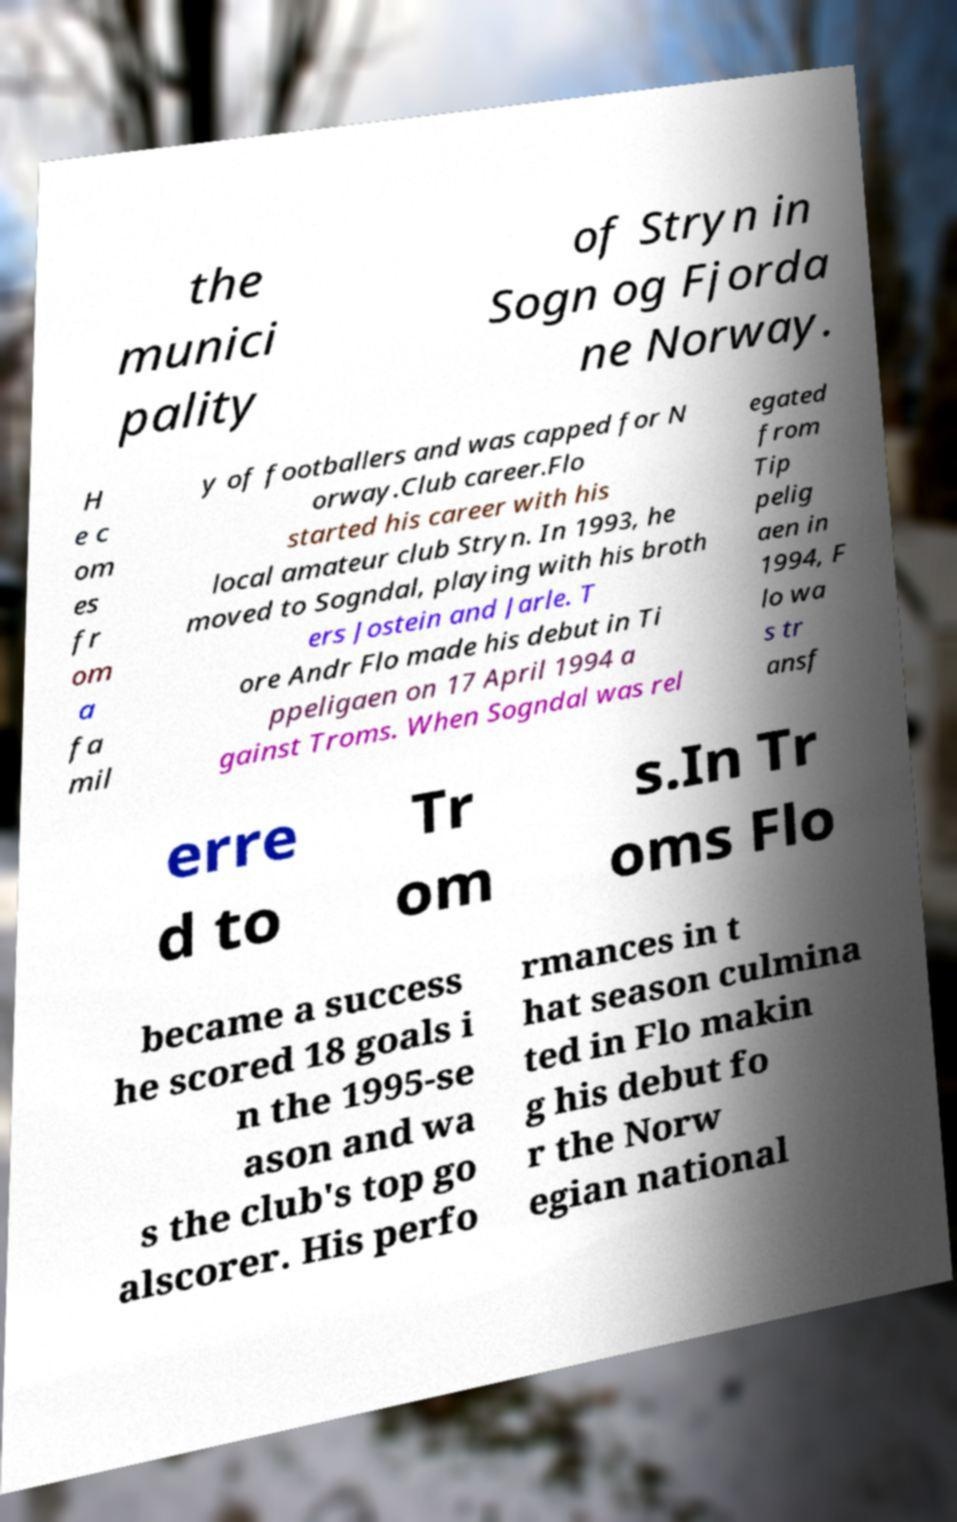Could you extract and type out the text from this image? the munici pality of Stryn in Sogn og Fjorda ne Norway. H e c om es fr om a fa mil y of footballers and was capped for N orway.Club career.Flo started his career with his local amateur club Stryn. In 1993, he moved to Sogndal, playing with his broth ers Jostein and Jarle. T ore Andr Flo made his debut in Ti ppeligaen on 17 April 1994 a gainst Troms. When Sogndal was rel egated from Tip pelig aen in 1994, F lo wa s tr ansf erre d to Tr om s.In Tr oms Flo became a success he scored 18 goals i n the 1995-se ason and wa s the club's top go alscorer. His perfo rmances in t hat season culmina ted in Flo makin g his debut fo r the Norw egian national 